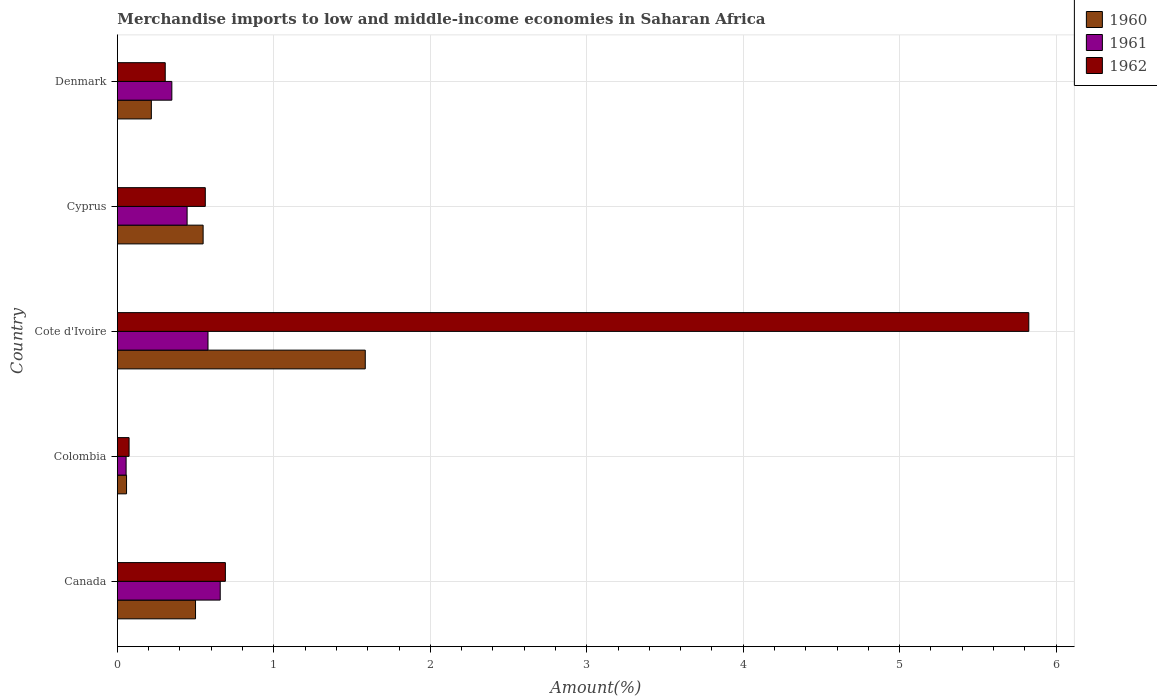How many groups of bars are there?
Your answer should be very brief. 5. Are the number of bars per tick equal to the number of legend labels?
Provide a succinct answer. Yes. Are the number of bars on each tick of the Y-axis equal?
Offer a terse response. Yes. How many bars are there on the 3rd tick from the bottom?
Offer a terse response. 3. What is the label of the 5th group of bars from the top?
Your answer should be compact. Canada. What is the percentage of amount earned from merchandise imports in 1960 in Cote d'Ivoire?
Offer a terse response. 1.58. Across all countries, what is the maximum percentage of amount earned from merchandise imports in 1961?
Make the answer very short. 0.66. Across all countries, what is the minimum percentage of amount earned from merchandise imports in 1962?
Make the answer very short. 0.07. What is the total percentage of amount earned from merchandise imports in 1962 in the graph?
Your answer should be very brief. 7.46. What is the difference between the percentage of amount earned from merchandise imports in 1962 in Canada and that in Cote d'Ivoire?
Provide a short and direct response. -5.14. What is the difference between the percentage of amount earned from merchandise imports in 1960 in Denmark and the percentage of amount earned from merchandise imports in 1961 in Colombia?
Your answer should be compact. 0.16. What is the average percentage of amount earned from merchandise imports in 1961 per country?
Your answer should be compact. 0.42. What is the difference between the percentage of amount earned from merchandise imports in 1961 and percentage of amount earned from merchandise imports in 1960 in Cyprus?
Provide a short and direct response. -0.1. In how many countries, is the percentage of amount earned from merchandise imports in 1960 greater than 4.2 %?
Keep it short and to the point. 0. What is the ratio of the percentage of amount earned from merchandise imports in 1961 in Canada to that in Colombia?
Your answer should be very brief. 11.8. Is the difference between the percentage of amount earned from merchandise imports in 1961 in Colombia and Denmark greater than the difference between the percentage of amount earned from merchandise imports in 1960 in Colombia and Denmark?
Keep it short and to the point. No. What is the difference between the highest and the second highest percentage of amount earned from merchandise imports in 1960?
Your answer should be very brief. 1.04. What is the difference between the highest and the lowest percentage of amount earned from merchandise imports in 1962?
Give a very brief answer. 5.75. In how many countries, is the percentage of amount earned from merchandise imports in 1961 greater than the average percentage of amount earned from merchandise imports in 1961 taken over all countries?
Give a very brief answer. 3. What does the 1st bar from the bottom in Colombia represents?
Your answer should be very brief. 1960. How many bars are there?
Make the answer very short. 15. What is the difference between two consecutive major ticks on the X-axis?
Ensure brevity in your answer.  1. Does the graph contain any zero values?
Give a very brief answer. No. Does the graph contain grids?
Your answer should be very brief. Yes. Where does the legend appear in the graph?
Your answer should be very brief. Top right. How are the legend labels stacked?
Your response must be concise. Vertical. What is the title of the graph?
Your answer should be compact. Merchandise imports to low and middle-income economies in Saharan Africa. What is the label or title of the X-axis?
Ensure brevity in your answer.  Amount(%). What is the label or title of the Y-axis?
Keep it short and to the point. Country. What is the Amount(%) in 1960 in Canada?
Make the answer very short. 0.5. What is the Amount(%) of 1961 in Canada?
Ensure brevity in your answer.  0.66. What is the Amount(%) in 1962 in Canada?
Provide a short and direct response. 0.69. What is the Amount(%) in 1960 in Colombia?
Provide a short and direct response. 0.06. What is the Amount(%) of 1961 in Colombia?
Make the answer very short. 0.06. What is the Amount(%) of 1962 in Colombia?
Offer a terse response. 0.07. What is the Amount(%) in 1960 in Cote d'Ivoire?
Give a very brief answer. 1.58. What is the Amount(%) of 1961 in Cote d'Ivoire?
Make the answer very short. 0.58. What is the Amount(%) of 1962 in Cote d'Ivoire?
Your answer should be compact. 5.83. What is the Amount(%) of 1960 in Cyprus?
Provide a succinct answer. 0.55. What is the Amount(%) of 1961 in Cyprus?
Offer a very short reply. 0.45. What is the Amount(%) of 1962 in Cyprus?
Your answer should be compact. 0.56. What is the Amount(%) of 1960 in Denmark?
Your answer should be compact. 0.22. What is the Amount(%) in 1961 in Denmark?
Make the answer very short. 0.35. What is the Amount(%) in 1962 in Denmark?
Make the answer very short. 0.31. Across all countries, what is the maximum Amount(%) of 1960?
Make the answer very short. 1.58. Across all countries, what is the maximum Amount(%) of 1961?
Offer a terse response. 0.66. Across all countries, what is the maximum Amount(%) in 1962?
Provide a succinct answer. 5.83. Across all countries, what is the minimum Amount(%) of 1960?
Offer a terse response. 0.06. Across all countries, what is the minimum Amount(%) of 1961?
Provide a short and direct response. 0.06. Across all countries, what is the minimum Amount(%) of 1962?
Offer a terse response. 0.07. What is the total Amount(%) of 1960 in the graph?
Keep it short and to the point. 2.91. What is the total Amount(%) in 1961 in the graph?
Offer a very short reply. 2.09. What is the total Amount(%) in 1962 in the graph?
Provide a short and direct response. 7.46. What is the difference between the Amount(%) in 1960 in Canada and that in Colombia?
Offer a terse response. 0.44. What is the difference between the Amount(%) of 1961 in Canada and that in Colombia?
Keep it short and to the point. 0.6. What is the difference between the Amount(%) in 1962 in Canada and that in Colombia?
Provide a succinct answer. 0.62. What is the difference between the Amount(%) in 1960 in Canada and that in Cote d'Ivoire?
Your answer should be compact. -1.08. What is the difference between the Amount(%) of 1961 in Canada and that in Cote d'Ivoire?
Offer a very short reply. 0.08. What is the difference between the Amount(%) in 1962 in Canada and that in Cote d'Ivoire?
Make the answer very short. -5.14. What is the difference between the Amount(%) of 1960 in Canada and that in Cyprus?
Your answer should be very brief. -0.05. What is the difference between the Amount(%) in 1961 in Canada and that in Cyprus?
Keep it short and to the point. 0.21. What is the difference between the Amount(%) in 1962 in Canada and that in Cyprus?
Provide a succinct answer. 0.13. What is the difference between the Amount(%) in 1960 in Canada and that in Denmark?
Provide a succinct answer. 0.28. What is the difference between the Amount(%) of 1961 in Canada and that in Denmark?
Your answer should be very brief. 0.31. What is the difference between the Amount(%) of 1962 in Canada and that in Denmark?
Keep it short and to the point. 0.38. What is the difference between the Amount(%) of 1960 in Colombia and that in Cote d'Ivoire?
Your answer should be compact. -1.53. What is the difference between the Amount(%) of 1961 in Colombia and that in Cote d'Ivoire?
Your answer should be compact. -0.52. What is the difference between the Amount(%) of 1962 in Colombia and that in Cote d'Ivoire?
Keep it short and to the point. -5.75. What is the difference between the Amount(%) of 1960 in Colombia and that in Cyprus?
Offer a very short reply. -0.49. What is the difference between the Amount(%) of 1961 in Colombia and that in Cyprus?
Ensure brevity in your answer.  -0.39. What is the difference between the Amount(%) in 1962 in Colombia and that in Cyprus?
Your response must be concise. -0.49. What is the difference between the Amount(%) of 1960 in Colombia and that in Denmark?
Offer a terse response. -0.16. What is the difference between the Amount(%) of 1961 in Colombia and that in Denmark?
Make the answer very short. -0.29. What is the difference between the Amount(%) in 1962 in Colombia and that in Denmark?
Ensure brevity in your answer.  -0.23. What is the difference between the Amount(%) of 1960 in Cote d'Ivoire and that in Cyprus?
Provide a succinct answer. 1.04. What is the difference between the Amount(%) of 1961 in Cote d'Ivoire and that in Cyprus?
Your answer should be very brief. 0.13. What is the difference between the Amount(%) in 1962 in Cote d'Ivoire and that in Cyprus?
Ensure brevity in your answer.  5.26. What is the difference between the Amount(%) of 1960 in Cote d'Ivoire and that in Denmark?
Provide a short and direct response. 1.37. What is the difference between the Amount(%) in 1961 in Cote d'Ivoire and that in Denmark?
Your response must be concise. 0.23. What is the difference between the Amount(%) of 1962 in Cote d'Ivoire and that in Denmark?
Your answer should be very brief. 5.52. What is the difference between the Amount(%) in 1960 in Cyprus and that in Denmark?
Give a very brief answer. 0.33. What is the difference between the Amount(%) of 1961 in Cyprus and that in Denmark?
Make the answer very short. 0.1. What is the difference between the Amount(%) of 1962 in Cyprus and that in Denmark?
Keep it short and to the point. 0.26. What is the difference between the Amount(%) in 1960 in Canada and the Amount(%) in 1961 in Colombia?
Your response must be concise. 0.44. What is the difference between the Amount(%) of 1960 in Canada and the Amount(%) of 1962 in Colombia?
Keep it short and to the point. 0.42. What is the difference between the Amount(%) of 1961 in Canada and the Amount(%) of 1962 in Colombia?
Keep it short and to the point. 0.58. What is the difference between the Amount(%) in 1960 in Canada and the Amount(%) in 1961 in Cote d'Ivoire?
Offer a terse response. -0.08. What is the difference between the Amount(%) of 1960 in Canada and the Amount(%) of 1962 in Cote d'Ivoire?
Your answer should be compact. -5.33. What is the difference between the Amount(%) in 1961 in Canada and the Amount(%) in 1962 in Cote d'Ivoire?
Your answer should be very brief. -5.17. What is the difference between the Amount(%) of 1960 in Canada and the Amount(%) of 1961 in Cyprus?
Offer a terse response. 0.05. What is the difference between the Amount(%) of 1960 in Canada and the Amount(%) of 1962 in Cyprus?
Provide a short and direct response. -0.06. What is the difference between the Amount(%) of 1961 in Canada and the Amount(%) of 1962 in Cyprus?
Offer a very short reply. 0.1. What is the difference between the Amount(%) of 1960 in Canada and the Amount(%) of 1961 in Denmark?
Offer a very short reply. 0.15. What is the difference between the Amount(%) of 1960 in Canada and the Amount(%) of 1962 in Denmark?
Offer a terse response. 0.19. What is the difference between the Amount(%) in 1961 in Canada and the Amount(%) in 1962 in Denmark?
Ensure brevity in your answer.  0.35. What is the difference between the Amount(%) of 1960 in Colombia and the Amount(%) of 1961 in Cote d'Ivoire?
Offer a terse response. -0.52. What is the difference between the Amount(%) in 1960 in Colombia and the Amount(%) in 1962 in Cote d'Ivoire?
Your response must be concise. -5.77. What is the difference between the Amount(%) of 1961 in Colombia and the Amount(%) of 1962 in Cote d'Ivoire?
Your response must be concise. -5.77. What is the difference between the Amount(%) of 1960 in Colombia and the Amount(%) of 1961 in Cyprus?
Offer a terse response. -0.39. What is the difference between the Amount(%) of 1960 in Colombia and the Amount(%) of 1962 in Cyprus?
Your answer should be compact. -0.5. What is the difference between the Amount(%) of 1961 in Colombia and the Amount(%) of 1962 in Cyprus?
Keep it short and to the point. -0.51. What is the difference between the Amount(%) in 1960 in Colombia and the Amount(%) in 1961 in Denmark?
Offer a terse response. -0.29. What is the difference between the Amount(%) of 1960 in Colombia and the Amount(%) of 1962 in Denmark?
Give a very brief answer. -0.25. What is the difference between the Amount(%) in 1961 in Colombia and the Amount(%) in 1962 in Denmark?
Your answer should be very brief. -0.25. What is the difference between the Amount(%) of 1960 in Cote d'Ivoire and the Amount(%) of 1961 in Cyprus?
Offer a very short reply. 1.14. What is the difference between the Amount(%) in 1960 in Cote d'Ivoire and the Amount(%) in 1962 in Cyprus?
Your response must be concise. 1.02. What is the difference between the Amount(%) in 1961 in Cote d'Ivoire and the Amount(%) in 1962 in Cyprus?
Provide a short and direct response. 0.02. What is the difference between the Amount(%) in 1960 in Cote d'Ivoire and the Amount(%) in 1961 in Denmark?
Your answer should be very brief. 1.24. What is the difference between the Amount(%) in 1960 in Cote d'Ivoire and the Amount(%) in 1962 in Denmark?
Make the answer very short. 1.28. What is the difference between the Amount(%) in 1961 in Cote d'Ivoire and the Amount(%) in 1962 in Denmark?
Keep it short and to the point. 0.27. What is the difference between the Amount(%) of 1960 in Cyprus and the Amount(%) of 1961 in Denmark?
Make the answer very short. 0.2. What is the difference between the Amount(%) of 1960 in Cyprus and the Amount(%) of 1962 in Denmark?
Give a very brief answer. 0.24. What is the difference between the Amount(%) of 1961 in Cyprus and the Amount(%) of 1962 in Denmark?
Offer a very short reply. 0.14. What is the average Amount(%) of 1960 per country?
Offer a very short reply. 0.58. What is the average Amount(%) of 1961 per country?
Offer a very short reply. 0.42. What is the average Amount(%) in 1962 per country?
Keep it short and to the point. 1.49. What is the difference between the Amount(%) in 1960 and Amount(%) in 1961 in Canada?
Offer a terse response. -0.16. What is the difference between the Amount(%) in 1960 and Amount(%) in 1962 in Canada?
Keep it short and to the point. -0.19. What is the difference between the Amount(%) of 1961 and Amount(%) of 1962 in Canada?
Your answer should be very brief. -0.03. What is the difference between the Amount(%) in 1960 and Amount(%) in 1961 in Colombia?
Provide a short and direct response. 0. What is the difference between the Amount(%) in 1960 and Amount(%) in 1962 in Colombia?
Ensure brevity in your answer.  -0.02. What is the difference between the Amount(%) of 1961 and Amount(%) of 1962 in Colombia?
Offer a very short reply. -0.02. What is the difference between the Amount(%) in 1960 and Amount(%) in 1962 in Cote d'Ivoire?
Keep it short and to the point. -4.24. What is the difference between the Amount(%) in 1961 and Amount(%) in 1962 in Cote d'Ivoire?
Your answer should be compact. -5.25. What is the difference between the Amount(%) in 1960 and Amount(%) in 1961 in Cyprus?
Provide a short and direct response. 0.1. What is the difference between the Amount(%) of 1960 and Amount(%) of 1962 in Cyprus?
Your response must be concise. -0.01. What is the difference between the Amount(%) of 1961 and Amount(%) of 1962 in Cyprus?
Ensure brevity in your answer.  -0.12. What is the difference between the Amount(%) of 1960 and Amount(%) of 1961 in Denmark?
Your answer should be compact. -0.13. What is the difference between the Amount(%) in 1960 and Amount(%) in 1962 in Denmark?
Keep it short and to the point. -0.09. What is the difference between the Amount(%) of 1961 and Amount(%) of 1962 in Denmark?
Offer a terse response. 0.04. What is the ratio of the Amount(%) of 1960 in Canada to that in Colombia?
Provide a short and direct response. 8.55. What is the ratio of the Amount(%) of 1961 in Canada to that in Colombia?
Offer a terse response. 11.8. What is the ratio of the Amount(%) of 1962 in Canada to that in Colombia?
Offer a very short reply. 9.25. What is the ratio of the Amount(%) of 1960 in Canada to that in Cote d'Ivoire?
Make the answer very short. 0.32. What is the ratio of the Amount(%) in 1961 in Canada to that in Cote d'Ivoire?
Your answer should be compact. 1.13. What is the ratio of the Amount(%) of 1962 in Canada to that in Cote d'Ivoire?
Provide a short and direct response. 0.12. What is the ratio of the Amount(%) of 1960 in Canada to that in Cyprus?
Keep it short and to the point. 0.91. What is the ratio of the Amount(%) of 1961 in Canada to that in Cyprus?
Offer a terse response. 1.47. What is the ratio of the Amount(%) in 1962 in Canada to that in Cyprus?
Give a very brief answer. 1.23. What is the ratio of the Amount(%) in 1960 in Canada to that in Denmark?
Provide a short and direct response. 2.3. What is the ratio of the Amount(%) in 1961 in Canada to that in Denmark?
Keep it short and to the point. 1.89. What is the ratio of the Amount(%) of 1962 in Canada to that in Denmark?
Make the answer very short. 2.26. What is the ratio of the Amount(%) of 1960 in Colombia to that in Cote d'Ivoire?
Provide a succinct answer. 0.04. What is the ratio of the Amount(%) of 1961 in Colombia to that in Cote d'Ivoire?
Provide a succinct answer. 0.1. What is the ratio of the Amount(%) in 1962 in Colombia to that in Cote d'Ivoire?
Provide a succinct answer. 0.01. What is the ratio of the Amount(%) of 1960 in Colombia to that in Cyprus?
Offer a very short reply. 0.11. What is the ratio of the Amount(%) in 1962 in Colombia to that in Cyprus?
Offer a very short reply. 0.13. What is the ratio of the Amount(%) of 1960 in Colombia to that in Denmark?
Your answer should be very brief. 0.27. What is the ratio of the Amount(%) in 1961 in Colombia to that in Denmark?
Provide a short and direct response. 0.16. What is the ratio of the Amount(%) of 1962 in Colombia to that in Denmark?
Your answer should be compact. 0.24. What is the ratio of the Amount(%) in 1960 in Cote d'Ivoire to that in Cyprus?
Your answer should be very brief. 2.89. What is the ratio of the Amount(%) in 1961 in Cote d'Ivoire to that in Cyprus?
Give a very brief answer. 1.3. What is the ratio of the Amount(%) in 1962 in Cote d'Ivoire to that in Cyprus?
Keep it short and to the point. 10.37. What is the ratio of the Amount(%) of 1960 in Cote d'Ivoire to that in Denmark?
Offer a terse response. 7.3. What is the ratio of the Amount(%) of 1961 in Cote d'Ivoire to that in Denmark?
Your answer should be compact. 1.66. What is the ratio of the Amount(%) in 1962 in Cote d'Ivoire to that in Denmark?
Your answer should be very brief. 19.05. What is the ratio of the Amount(%) of 1960 in Cyprus to that in Denmark?
Offer a very short reply. 2.53. What is the ratio of the Amount(%) of 1961 in Cyprus to that in Denmark?
Provide a succinct answer. 1.28. What is the ratio of the Amount(%) in 1962 in Cyprus to that in Denmark?
Your answer should be compact. 1.84. What is the difference between the highest and the second highest Amount(%) in 1960?
Your response must be concise. 1.04. What is the difference between the highest and the second highest Amount(%) of 1961?
Give a very brief answer. 0.08. What is the difference between the highest and the second highest Amount(%) in 1962?
Keep it short and to the point. 5.14. What is the difference between the highest and the lowest Amount(%) in 1960?
Offer a terse response. 1.53. What is the difference between the highest and the lowest Amount(%) in 1961?
Make the answer very short. 0.6. What is the difference between the highest and the lowest Amount(%) in 1962?
Your answer should be compact. 5.75. 